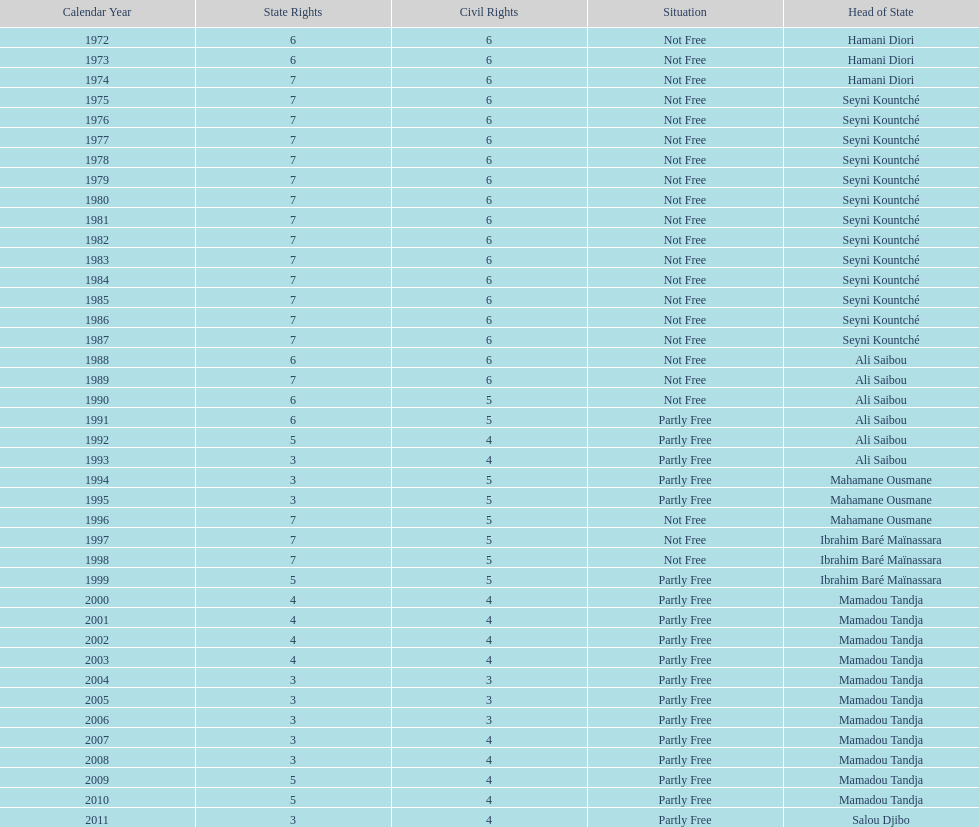Who is the next president listed after hamani diori in the year 1974? Seyni Kountché. Give me the full table as a dictionary. {'header': ['Calendar Year', 'State Rights', 'Civil Rights', 'Situation', 'Head of State'], 'rows': [['1972', '6', '6', 'Not Free', 'Hamani Diori'], ['1973', '6', '6', 'Not Free', 'Hamani Diori'], ['1974', '7', '6', 'Not Free', 'Hamani Diori'], ['1975', '7', '6', 'Not Free', 'Seyni Kountché'], ['1976', '7', '6', 'Not Free', 'Seyni Kountché'], ['1977', '7', '6', 'Not Free', 'Seyni Kountché'], ['1978', '7', '6', 'Not Free', 'Seyni Kountché'], ['1979', '7', '6', 'Not Free', 'Seyni Kountché'], ['1980', '7', '6', 'Not Free', 'Seyni Kountché'], ['1981', '7', '6', 'Not Free', 'Seyni Kountché'], ['1982', '7', '6', 'Not Free', 'Seyni Kountché'], ['1983', '7', '6', 'Not Free', 'Seyni Kountché'], ['1984', '7', '6', 'Not Free', 'Seyni Kountché'], ['1985', '7', '6', 'Not Free', 'Seyni Kountché'], ['1986', '7', '6', 'Not Free', 'Seyni Kountché'], ['1987', '7', '6', 'Not Free', 'Seyni Kountché'], ['1988', '6', '6', 'Not Free', 'Ali Saibou'], ['1989', '7', '6', 'Not Free', 'Ali Saibou'], ['1990', '6', '5', 'Not Free', 'Ali Saibou'], ['1991', '6', '5', 'Partly Free', 'Ali Saibou'], ['1992', '5', '4', 'Partly Free', 'Ali Saibou'], ['1993', '3', '4', 'Partly Free', 'Ali Saibou'], ['1994', '3', '5', 'Partly Free', 'Mahamane Ousmane'], ['1995', '3', '5', 'Partly Free', 'Mahamane Ousmane'], ['1996', '7', '5', 'Not Free', 'Mahamane Ousmane'], ['1997', '7', '5', 'Not Free', 'Ibrahim Baré Maïnassara'], ['1998', '7', '5', 'Not Free', 'Ibrahim Baré Maïnassara'], ['1999', '5', '5', 'Partly Free', 'Ibrahim Baré Maïnassara'], ['2000', '4', '4', 'Partly Free', 'Mamadou Tandja'], ['2001', '4', '4', 'Partly Free', 'Mamadou Tandja'], ['2002', '4', '4', 'Partly Free', 'Mamadou Tandja'], ['2003', '4', '4', 'Partly Free', 'Mamadou Tandja'], ['2004', '3', '3', 'Partly Free', 'Mamadou Tandja'], ['2005', '3', '3', 'Partly Free', 'Mamadou Tandja'], ['2006', '3', '3', 'Partly Free', 'Mamadou Tandja'], ['2007', '3', '4', 'Partly Free', 'Mamadou Tandja'], ['2008', '3', '4', 'Partly Free', 'Mamadou Tandja'], ['2009', '5', '4', 'Partly Free', 'Mamadou Tandja'], ['2010', '5', '4', 'Partly Free', 'Mamadou Tandja'], ['2011', '3', '4', 'Partly Free', 'Salou Djibo']]} 